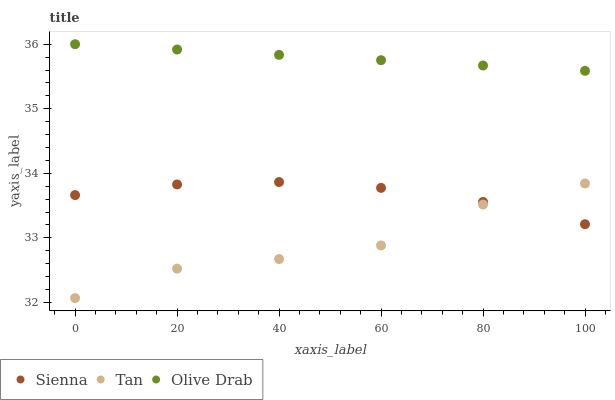Does Tan have the minimum area under the curve?
Answer yes or no. Yes. Does Olive Drab have the maximum area under the curve?
Answer yes or no. Yes. Does Olive Drab have the minimum area under the curve?
Answer yes or no. No. Does Tan have the maximum area under the curve?
Answer yes or no. No. Is Olive Drab the smoothest?
Answer yes or no. Yes. Is Tan the roughest?
Answer yes or no. Yes. Is Tan the smoothest?
Answer yes or no. No. Is Olive Drab the roughest?
Answer yes or no. No. Does Tan have the lowest value?
Answer yes or no. Yes. Does Olive Drab have the lowest value?
Answer yes or no. No. Does Olive Drab have the highest value?
Answer yes or no. Yes. Does Tan have the highest value?
Answer yes or no. No. Is Sienna less than Olive Drab?
Answer yes or no. Yes. Is Olive Drab greater than Tan?
Answer yes or no. Yes. Does Tan intersect Sienna?
Answer yes or no. Yes. Is Tan less than Sienna?
Answer yes or no. No. Is Tan greater than Sienna?
Answer yes or no. No. Does Sienna intersect Olive Drab?
Answer yes or no. No. 